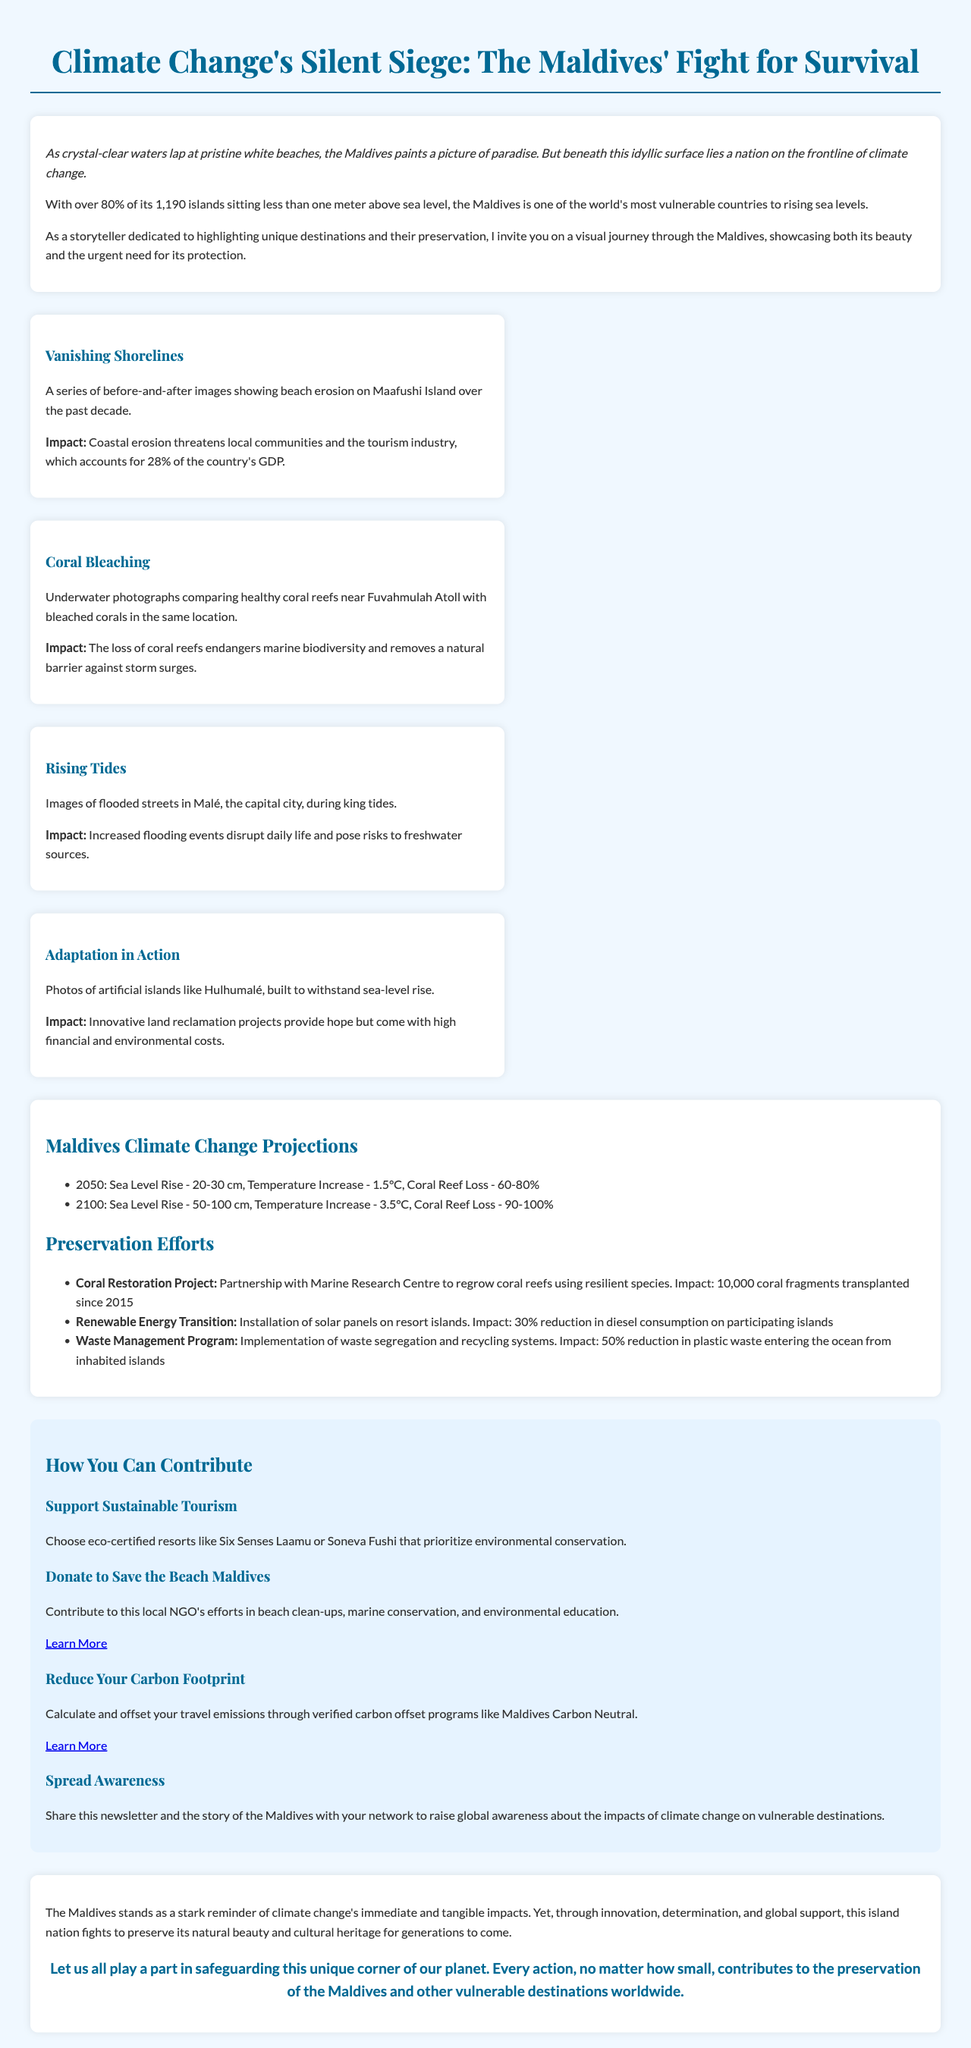what percentage of the Maldives' GDP is accounted for by tourism? The document states that coastal erosion threatens local communities and the tourism industry, which accounts for 28% of the country's GDP.
Answer: 28% what is the expected coral reef loss by 2100? The infographic provides projections, indicating that by 2100, coral reef loss is anticipated to be between 90-100%.
Answer: 90-100% what is the impact of the Coral Restoration Project? The document mentions that the Coral Restoration Project has transplanted 10,000 coral fragments since 2015.
Answer: 10,000 coral fragments what innovative land reclamation project provides hope for the Maldives? The document references artificial islands built to withstand sea-level rise, specifically mentioning Hulhumalé.
Answer: Hulhumalé how can one contribute to beach clean-ups in the Maldives? The document suggests donating to Save the Beach Maldives for this purpose.
Answer: Donate to Save the Beach Maldives what is the temperature increase projected for the year 2050? According to the infographic, the temperature increase projected for 2050 is 1.5°C.
Answer: 1.5°C what initiative reduces plastic waste entering the ocean from inhabited islands? The Waste Management Program is implemented to reduce plastic waste entering the ocean.
Answer: Waste Management Program how much has diesel consumption reduced on participating islands? The Renewable Energy Transition initiative has led to a 30% reduction in diesel consumption on participating islands.
Answer: 30% what is the call to action at the end of the newsletter? The conclusion encourages readers to play a part in safeguarding unique destinations, emphasizing that every action counts.
Answer: Every action contributes to preservation 